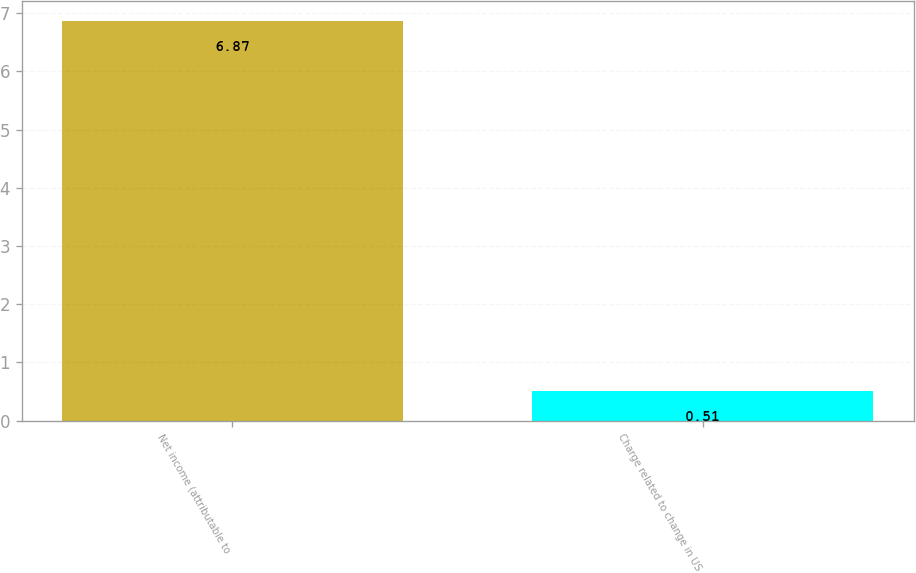Convert chart. <chart><loc_0><loc_0><loc_500><loc_500><bar_chart><fcel>Net income (attributable to<fcel>Charge related to change in US<nl><fcel>6.87<fcel>0.51<nl></chart> 